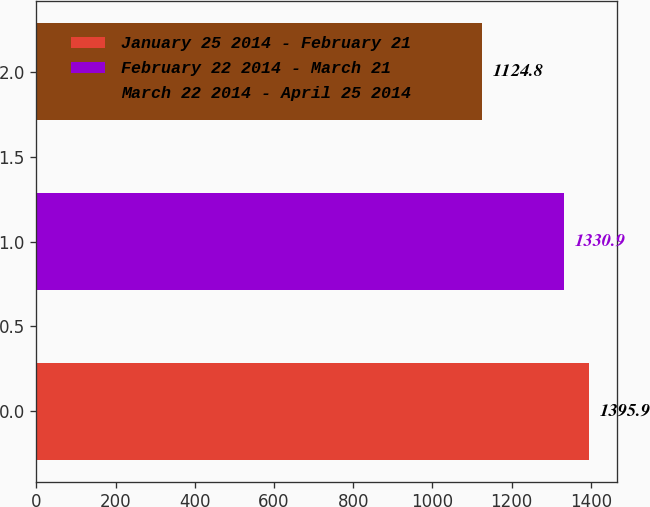<chart> <loc_0><loc_0><loc_500><loc_500><bar_chart><fcel>January 25 2014 - February 21<fcel>February 22 2014 - March 21<fcel>March 22 2014 - April 25 2014<nl><fcel>1395.9<fcel>1330.9<fcel>1124.8<nl></chart> 